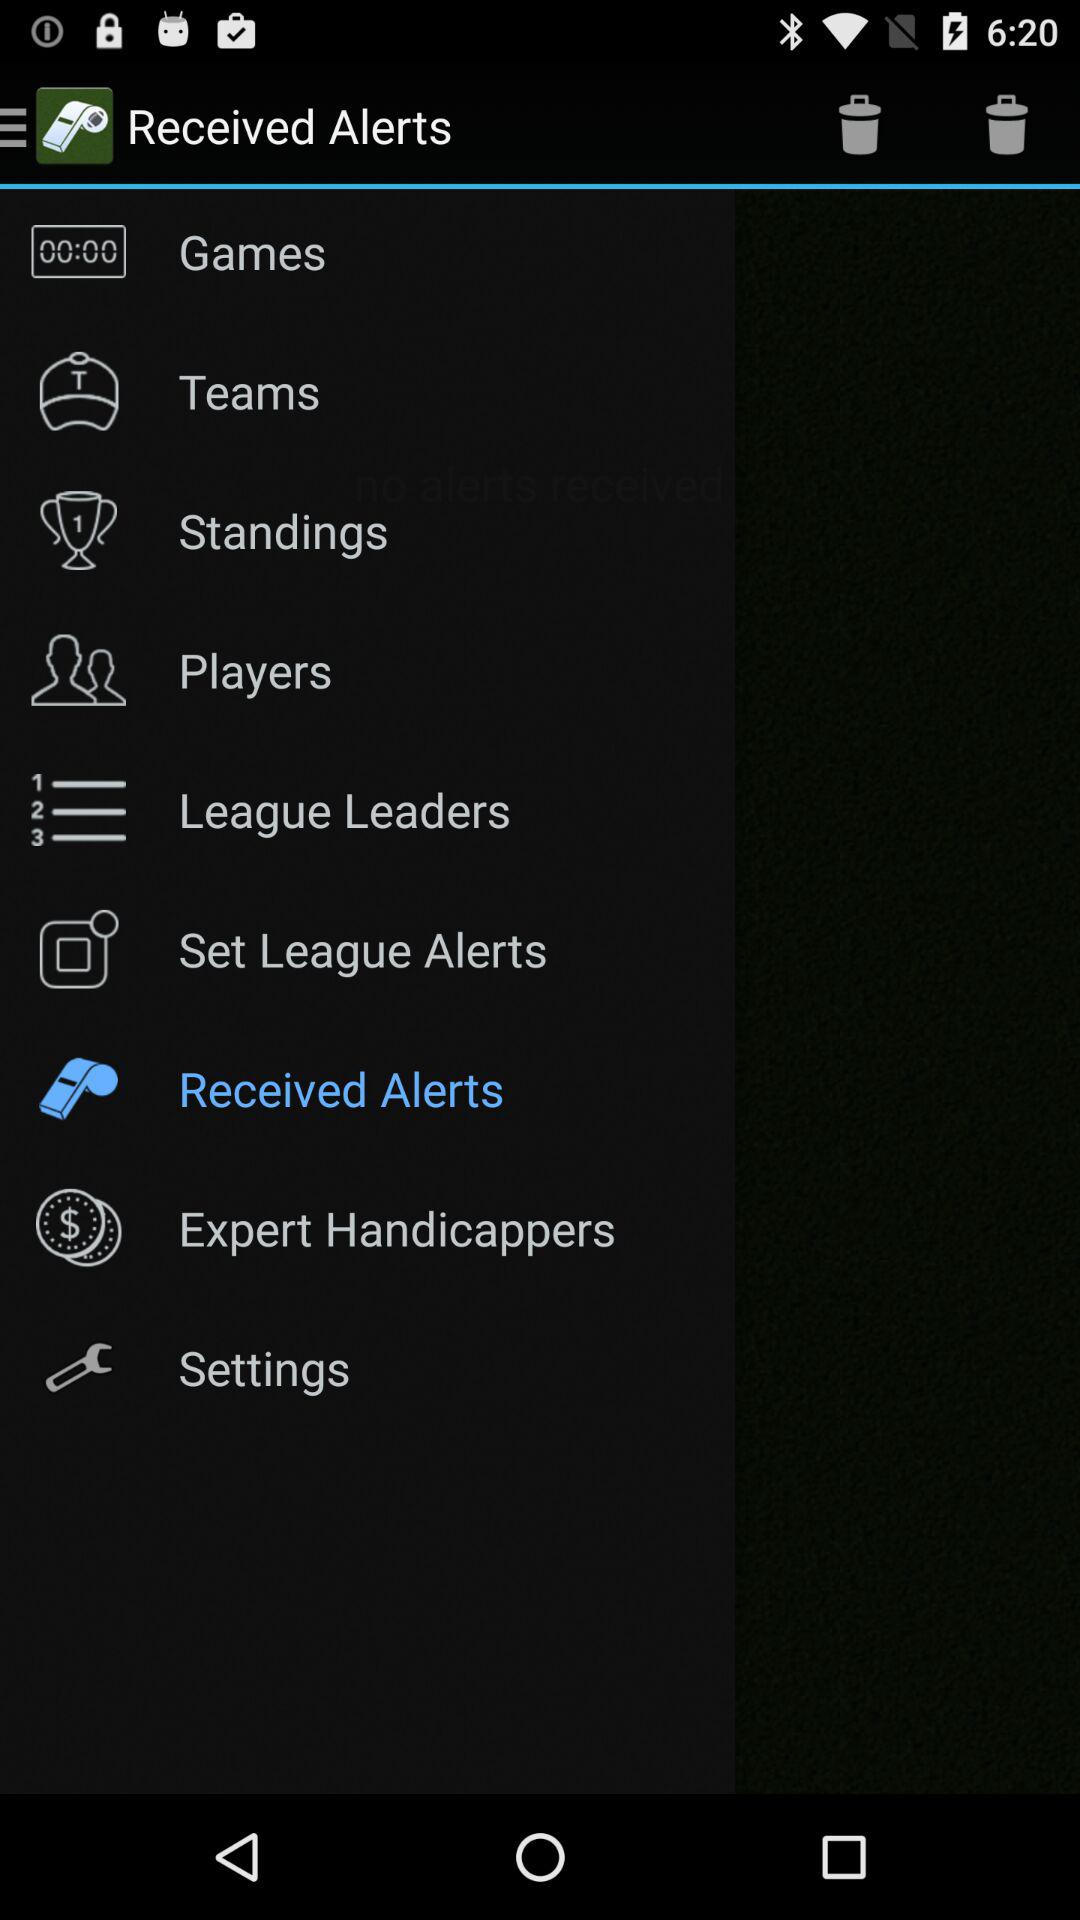Which item is selected? The selected item is "Received Alerts". 